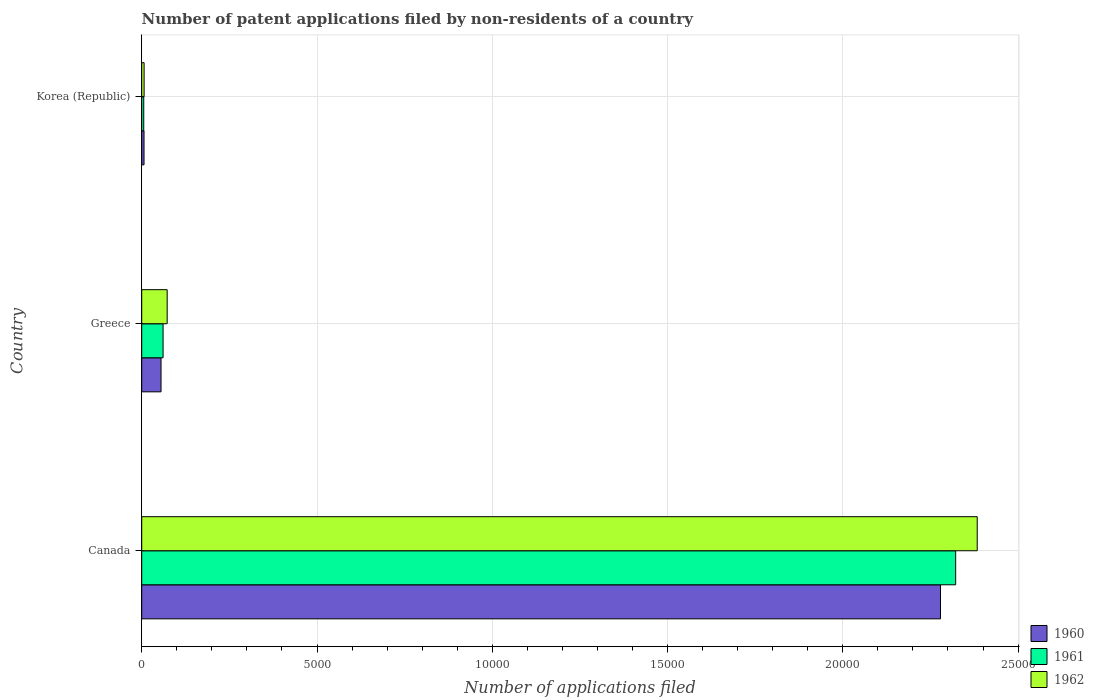How many groups of bars are there?
Offer a terse response. 3. Are the number of bars on each tick of the Y-axis equal?
Offer a terse response. Yes. In how many cases, is the number of bars for a given country not equal to the number of legend labels?
Make the answer very short. 0. What is the number of applications filed in 1961 in Canada?
Your answer should be very brief. 2.32e+04. Across all countries, what is the maximum number of applications filed in 1962?
Make the answer very short. 2.38e+04. In which country was the number of applications filed in 1961 maximum?
Offer a very short reply. Canada. In which country was the number of applications filed in 1962 minimum?
Provide a succinct answer. Korea (Republic). What is the total number of applications filed in 1960 in the graph?
Your answer should be compact. 2.34e+04. What is the difference between the number of applications filed in 1960 in Canada and that in Greece?
Ensure brevity in your answer.  2.22e+04. What is the difference between the number of applications filed in 1962 in Greece and the number of applications filed in 1961 in Canada?
Provide a succinct answer. -2.25e+04. What is the average number of applications filed in 1960 per country?
Ensure brevity in your answer.  7801. What is the difference between the number of applications filed in 1960 and number of applications filed in 1961 in Greece?
Give a very brief answer. -58. In how many countries, is the number of applications filed in 1962 greater than 4000 ?
Offer a terse response. 1. Is the number of applications filed in 1962 in Canada less than that in Greece?
Offer a very short reply. No. Is the difference between the number of applications filed in 1960 in Canada and Korea (Republic) greater than the difference between the number of applications filed in 1961 in Canada and Korea (Republic)?
Your answer should be compact. No. What is the difference between the highest and the second highest number of applications filed in 1962?
Your answer should be compact. 2.31e+04. What is the difference between the highest and the lowest number of applications filed in 1961?
Offer a very short reply. 2.32e+04. Are all the bars in the graph horizontal?
Give a very brief answer. Yes. How many countries are there in the graph?
Keep it short and to the point. 3. Does the graph contain grids?
Offer a very short reply. Yes. Where does the legend appear in the graph?
Your answer should be very brief. Bottom right. How are the legend labels stacked?
Your answer should be very brief. Vertical. What is the title of the graph?
Your response must be concise. Number of patent applications filed by non-residents of a country. Does "1973" appear as one of the legend labels in the graph?
Offer a very short reply. No. What is the label or title of the X-axis?
Keep it short and to the point. Number of applications filed. What is the Number of applications filed of 1960 in Canada?
Ensure brevity in your answer.  2.28e+04. What is the Number of applications filed of 1961 in Canada?
Make the answer very short. 2.32e+04. What is the Number of applications filed of 1962 in Canada?
Your response must be concise. 2.38e+04. What is the Number of applications filed of 1960 in Greece?
Offer a terse response. 551. What is the Number of applications filed in 1961 in Greece?
Provide a short and direct response. 609. What is the Number of applications filed in 1962 in Greece?
Keep it short and to the point. 726. What is the Number of applications filed in 1962 in Korea (Republic)?
Your response must be concise. 68. Across all countries, what is the maximum Number of applications filed of 1960?
Make the answer very short. 2.28e+04. Across all countries, what is the maximum Number of applications filed in 1961?
Give a very brief answer. 2.32e+04. Across all countries, what is the maximum Number of applications filed of 1962?
Offer a very short reply. 2.38e+04. Across all countries, what is the minimum Number of applications filed of 1962?
Your response must be concise. 68. What is the total Number of applications filed of 1960 in the graph?
Your answer should be very brief. 2.34e+04. What is the total Number of applications filed in 1961 in the graph?
Offer a very short reply. 2.39e+04. What is the total Number of applications filed in 1962 in the graph?
Your response must be concise. 2.46e+04. What is the difference between the Number of applications filed in 1960 in Canada and that in Greece?
Make the answer very short. 2.22e+04. What is the difference between the Number of applications filed of 1961 in Canada and that in Greece?
Offer a terse response. 2.26e+04. What is the difference between the Number of applications filed of 1962 in Canada and that in Greece?
Offer a very short reply. 2.31e+04. What is the difference between the Number of applications filed in 1960 in Canada and that in Korea (Republic)?
Provide a short and direct response. 2.27e+04. What is the difference between the Number of applications filed in 1961 in Canada and that in Korea (Republic)?
Your response must be concise. 2.32e+04. What is the difference between the Number of applications filed of 1962 in Canada and that in Korea (Republic)?
Make the answer very short. 2.38e+04. What is the difference between the Number of applications filed of 1960 in Greece and that in Korea (Republic)?
Offer a very short reply. 485. What is the difference between the Number of applications filed in 1961 in Greece and that in Korea (Republic)?
Your answer should be compact. 551. What is the difference between the Number of applications filed of 1962 in Greece and that in Korea (Republic)?
Your answer should be compact. 658. What is the difference between the Number of applications filed in 1960 in Canada and the Number of applications filed in 1961 in Greece?
Make the answer very short. 2.22e+04. What is the difference between the Number of applications filed in 1960 in Canada and the Number of applications filed in 1962 in Greece?
Provide a succinct answer. 2.21e+04. What is the difference between the Number of applications filed in 1961 in Canada and the Number of applications filed in 1962 in Greece?
Give a very brief answer. 2.25e+04. What is the difference between the Number of applications filed in 1960 in Canada and the Number of applications filed in 1961 in Korea (Republic)?
Your response must be concise. 2.27e+04. What is the difference between the Number of applications filed in 1960 in Canada and the Number of applications filed in 1962 in Korea (Republic)?
Provide a succinct answer. 2.27e+04. What is the difference between the Number of applications filed in 1961 in Canada and the Number of applications filed in 1962 in Korea (Republic)?
Your answer should be compact. 2.32e+04. What is the difference between the Number of applications filed of 1960 in Greece and the Number of applications filed of 1961 in Korea (Republic)?
Give a very brief answer. 493. What is the difference between the Number of applications filed in 1960 in Greece and the Number of applications filed in 1962 in Korea (Republic)?
Give a very brief answer. 483. What is the difference between the Number of applications filed in 1961 in Greece and the Number of applications filed in 1962 in Korea (Republic)?
Provide a short and direct response. 541. What is the average Number of applications filed in 1960 per country?
Provide a succinct answer. 7801. What is the average Number of applications filed in 1961 per country?
Provide a short and direct response. 7962. What is the average Number of applications filed of 1962 per country?
Offer a very short reply. 8209.33. What is the difference between the Number of applications filed in 1960 and Number of applications filed in 1961 in Canada?
Your answer should be very brief. -433. What is the difference between the Number of applications filed in 1960 and Number of applications filed in 1962 in Canada?
Offer a terse response. -1048. What is the difference between the Number of applications filed of 1961 and Number of applications filed of 1962 in Canada?
Make the answer very short. -615. What is the difference between the Number of applications filed in 1960 and Number of applications filed in 1961 in Greece?
Offer a very short reply. -58. What is the difference between the Number of applications filed in 1960 and Number of applications filed in 1962 in Greece?
Keep it short and to the point. -175. What is the difference between the Number of applications filed of 1961 and Number of applications filed of 1962 in Greece?
Your answer should be compact. -117. What is the difference between the Number of applications filed in 1960 and Number of applications filed in 1962 in Korea (Republic)?
Your answer should be compact. -2. What is the ratio of the Number of applications filed in 1960 in Canada to that in Greece?
Make the answer very short. 41.35. What is the ratio of the Number of applications filed in 1961 in Canada to that in Greece?
Give a very brief answer. 38.13. What is the ratio of the Number of applications filed of 1962 in Canada to that in Greece?
Your response must be concise. 32.83. What is the ratio of the Number of applications filed in 1960 in Canada to that in Korea (Republic)?
Keep it short and to the point. 345.24. What is the ratio of the Number of applications filed of 1961 in Canada to that in Korea (Republic)?
Your response must be concise. 400.33. What is the ratio of the Number of applications filed in 1962 in Canada to that in Korea (Republic)?
Provide a succinct answer. 350.5. What is the ratio of the Number of applications filed of 1960 in Greece to that in Korea (Republic)?
Provide a succinct answer. 8.35. What is the ratio of the Number of applications filed of 1962 in Greece to that in Korea (Republic)?
Make the answer very short. 10.68. What is the difference between the highest and the second highest Number of applications filed in 1960?
Provide a short and direct response. 2.22e+04. What is the difference between the highest and the second highest Number of applications filed of 1961?
Your answer should be very brief. 2.26e+04. What is the difference between the highest and the second highest Number of applications filed of 1962?
Keep it short and to the point. 2.31e+04. What is the difference between the highest and the lowest Number of applications filed of 1960?
Offer a very short reply. 2.27e+04. What is the difference between the highest and the lowest Number of applications filed of 1961?
Your answer should be very brief. 2.32e+04. What is the difference between the highest and the lowest Number of applications filed in 1962?
Your answer should be compact. 2.38e+04. 